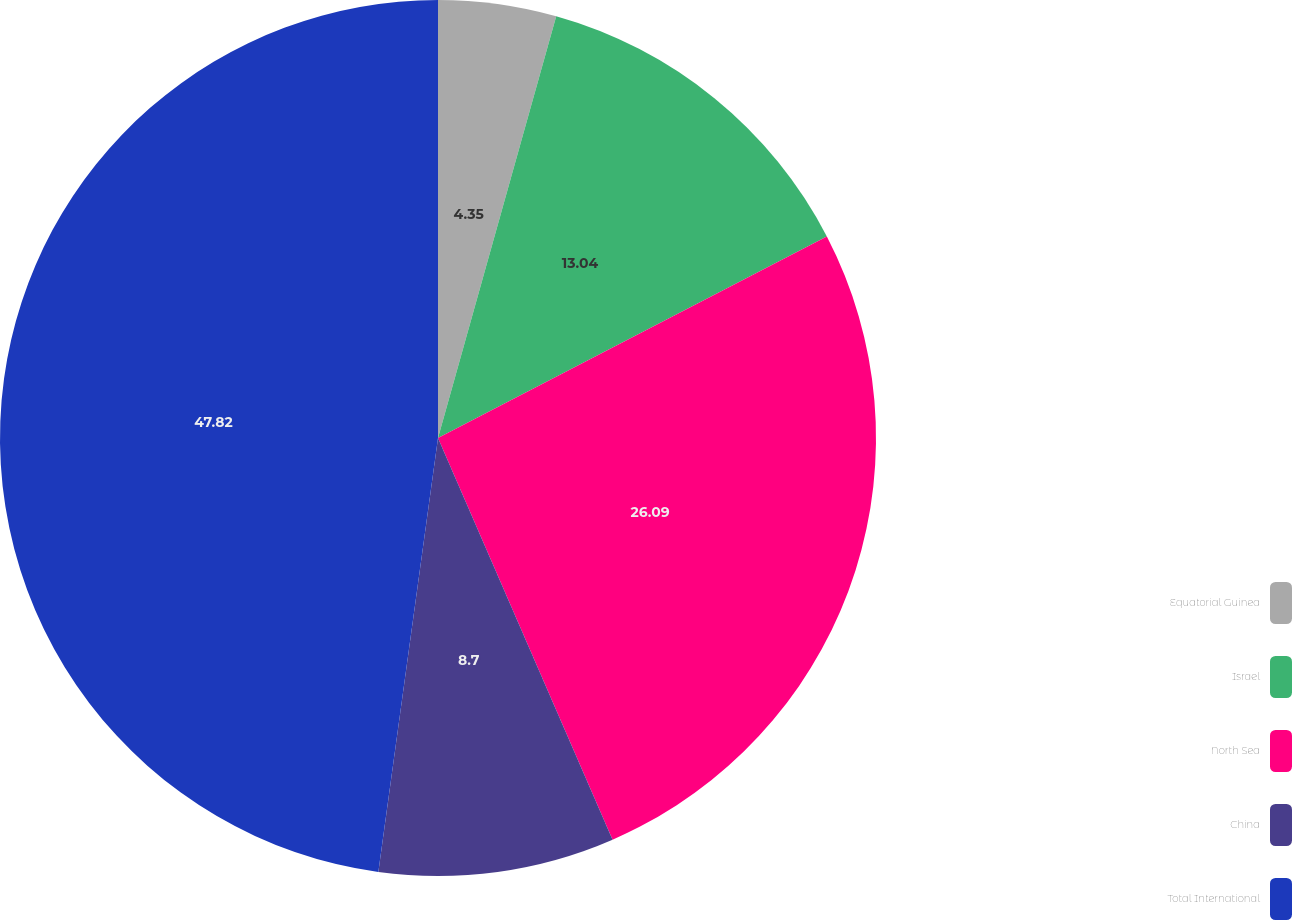Convert chart. <chart><loc_0><loc_0><loc_500><loc_500><pie_chart><fcel>Equatorial Guinea<fcel>Israel<fcel>North Sea<fcel>China<fcel>Total International<nl><fcel>4.35%<fcel>13.04%<fcel>26.09%<fcel>8.7%<fcel>47.83%<nl></chart> 